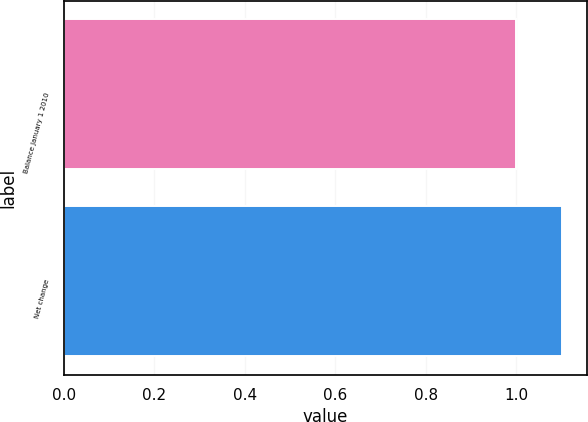Convert chart to OTSL. <chart><loc_0><loc_0><loc_500><loc_500><bar_chart><fcel>Balance January 1 2010<fcel>Net change<nl><fcel>1<fcel>1.1<nl></chart> 